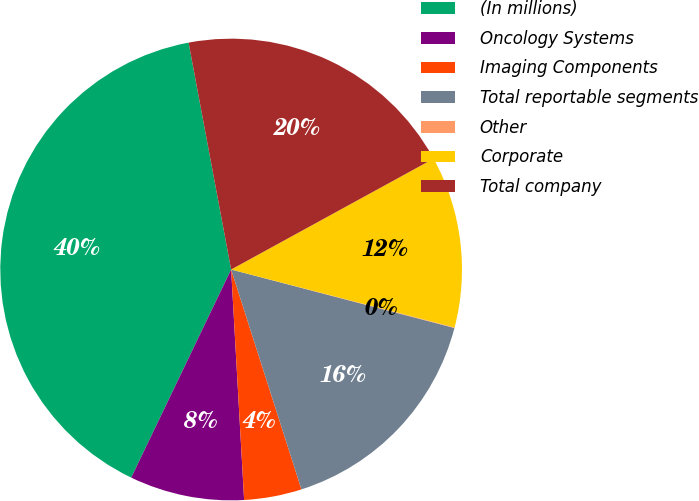Convert chart to OTSL. <chart><loc_0><loc_0><loc_500><loc_500><pie_chart><fcel>(In millions)<fcel>Oncology Systems<fcel>Imaging Components<fcel>Total reportable segments<fcel>Other<fcel>Corporate<fcel>Total company<nl><fcel>39.93%<fcel>8.02%<fcel>4.03%<fcel>16.0%<fcel>0.04%<fcel>12.01%<fcel>19.98%<nl></chart> 